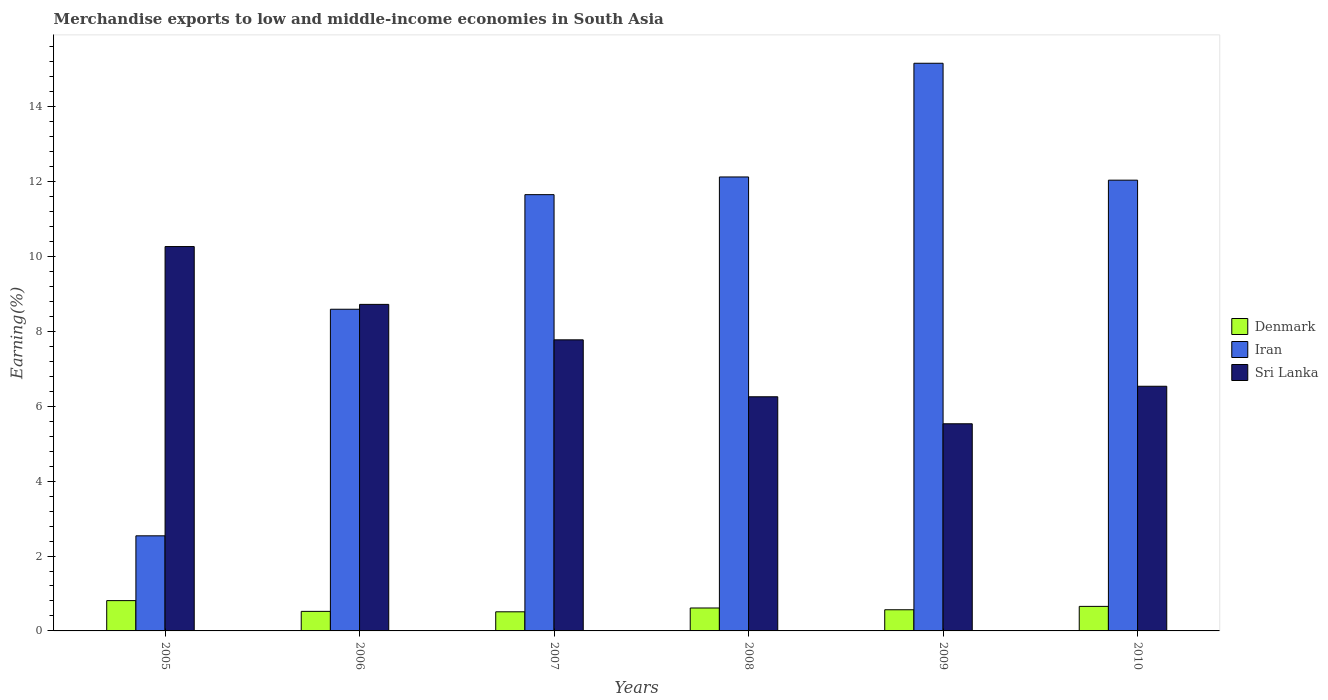How many different coloured bars are there?
Keep it short and to the point. 3. How many groups of bars are there?
Your response must be concise. 6. Are the number of bars on each tick of the X-axis equal?
Offer a terse response. Yes. How many bars are there on the 2nd tick from the right?
Make the answer very short. 3. What is the percentage of amount earned from merchandise exports in Sri Lanka in 2005?
Your answer should be compact. 10.27. Across all years, what is the maximum percentage of amount earned from merchandise exports in Sri Lanka?
Offer a terse response. 10.27. Across all years, what is the minimum percentage of amount earned from merchandise exports in Sri Lanka?
Your response must be concise. 5.53. In which year was the percentage of amount earned from merchandise exports in Iran minimum?
Keep it short and to the point. 2005. What is the total percentage of amount earned from merchandise exports in Denmark in the graph?
Offer a terse response. 3.68. What is the difference between the percentage of amount earned from merchandise exports in Iran in 2007 and that in 2009?
Give a very brief answer. -3.51. What is the difference between the percentage of amount earned from merchandise exports in Iran in 2005 and the percentage of amount earned from merchandise exports in Sri Lanka in 2006?
Make the answer very short. -6.18. What is the average percentage of amount earned from merchandise exports in Denmark per year?
Provide a succinct answer. 0.61. In the year 2007, what is the difference between the percentage of amount earned from merchandise exports in Denmark and percentage of amount earned from merchandise exports in Iran?
Your response must be concise. -11.14. In how many years, is the percentage of amount earned from merchandise exports in Iran greater than 11.6 %?
Your response must be concise. 4. What is the ratio of the percentage of amount earned from merchandise exports in Denmark in 2005 to that in 2008?
Offer a terse response. 1.32. Is the difference between the percentage of amount earned from merchandise exports in Denmark in 2006 and 2010 greater than the difference between the percentage of amount earned from merchandise exports in Iran in 2006 and 2010?
Your response must be concise. Yes. What is the difference between the highest and the second highest percentage of amount earned from merchandise exports in Denmark?
Your answer should be compact. 0.15. What is the difference between the highest and the lowest percentage of amount earned from merchandise exports in Denmark?
Your response must be concise. 0.3. In how many years, is the percentage of amount earned from merchandise exports in Sri Lanka greater than the average percentage of amount earned from merchandise exports in Sri Lanka taken over all years?
Provide a succinct answer. 3. What does the 2nd bar from the left in 2006 represents?
Provide a succinct answer. Iran. What does the 3rd bar from the right in 2010 represents?
Provide a short and direct response. Denmark. Is it the case that in every year, the sum of the percentage of amount earned from merchandise exports in Denmark and percentage of amount earned from merchandise exports in Sri Lanka is greater than the percentage of amount earned from merchandise exports in Iran?
Your answer should be compact. No. How many bars are there?
Offer a very short reply. 18. How many years are there in the graph?
Provide a succinct answer. 6. Does the graph contain any zero values?
Offer a very short reply. No. Does the graph contain grids?
Offer a very short reply. No. Where does the legend appear in the graph?
Offer a very short reply. Center right. How are the legend labels stacked?
Keep it short and to the point. Vertical. What is the title of the graph?
Offer a terse response. Merchandise exports to low and middle-income economies in South Asia. Does "Congo (Republic)" appear as one of the legend labels in the graph?
Give a very brief answer. No. What is the label or title of the Y-axis?
Keep it short and to the point. Earning(%). What is the Earning(%) of Denmark in 2005?
Provide a short and direct response. 0.81. What is the Earning(%) of Iran in 2005?
Make the answer very short. 2.54. What is the Earning(%) of Sri Lanka in 2005?
Offer a very short reply. 10.27. What is the Earning(%) in Denmark in 2006?
Make the answer very short. 0.52. What is the Earning(%) in Iran in 2006?
Provide a succinct answer. 8.59. What is the Earning(%) in Sri Lanka in 2006?
Give a very brief answer. 8.72. What is the Earning(%) in Denmark in 2007?
Your answer should be very brief. 0.51. What is the Earning(%) of Iran in 2007?
Your response must be concise. 11.65. What is the Earning(%) in Sri Lanka in 2007?
Make the answer very short. 7.78. What is the Earning(%) in Denmark in 2008?
Give a very brief answer. 0.61. What is the Earning(%) in Iran in 2008?
Offer a terse response. 12.13. What is the Earning(%) in Sri Lanka in 2008?
Make the answer very short. 6.25. What is the Earning(%) of Denmark in 2009?
Provide a succinct answer. 0.57. What is the Earning(%) in Iran in 2009?
Provide a short and direct response. 15.16. What is the Earning(%) in Sri Lanka in 2009?
Your answer should be very brief. 5.53. What is the Earning(%) in Denmark in 2010?
Provide a short and direct response. 0.66. What is the Earning(%) of Iran in 2010?
Ensure brevity in your answer.  12.04. What is the Earning(%) in Sri Lanka in 2010?
Make the answer very short. 6.54. Across all years, what is the maximum Earning(%) in Denmark?
Make the answer very short. 0.81. Across all years, what is the maximum Earning(%) in Iran?
Offer a very short reply. 15.16. Across all years, what is the maximum Earning(%) in Sri Lanka?
Your answer should be compact. 10.27. Across all years, what is the minimum Earning(%) in Denmark?
Your answer should be compact. 0.51. Across all years, what is the minimum Earning(%) in Iran?
Make the answer very short. 2.54. Across all years, what is the minimum Earning(%) in Sri Lanka?
Keep it short and to the point. 5.53. What is the total Earning(%) of Denmark in the graph?
Offer a very short reply. 3.68. What is the total Earning(%) in Iran in the graph?
Your answer should be compact. 62.12. What is the total Earning(%) in Sri Lanka in the graph?
Provide a succinct answer. 45.09. What is the difference between the Earning(%) of Denmark in 2005 and that in 2006?
Make the answer very short. 0.29. What is the difference between the Earning(%) in Iran in 2005 and that in 2006?
Ensure brevity in your answer.  -6.05. What is the difference between the Earning(%) in Sri Lanka in 2005 and that in 2006?
Provide a short and direct response. 1.54. What is the difference between the Earning(%) of Denmark in 2005 and that in 2007?
Provide a succinct answer. 0.3. What is the difference between the Earning(%) in Iran in 2005 and that in 2007?
Ensure brevity in your answer.  -9.11. What is the difference between the Earning(%) of Sri Lanka in 2005 and that in 2007?
Ensure brevity in your answer.  2.49. What is the difference between the Earning(%) of Denmark in 2005 and that in 2008?
Your answer should be compact. 0.2. What is the difference between the Earning(%) in Iran in 2005 and that in 2008?
Offer a very short reply. -9.59. What is the difference between the Earning(%) in Sri Lanka in 2005 and that in 2008?
Provide a succinct answer. 4.01. What is the difference between the Earning(%) in Denmark in 2005 and that in 2009?
Ensure brevity in your answer.  0.24. What is the difference between the Earning(%) in Iran in 2005 and that in 2009?
Give a very brief answer. -12.62. What is the difference between the Earning(%) of Sri Lanka in 2005 and that in 2009?
Your answer should be compact. 4.73. What is the difference between the Earning(%) in Denmark in 2005 and that in 2010?
Your answer should be very brief. 0.15. What is the difference between the Earning(%) of Iran in 2005 and that in 2010?
Your response must be concise. -9.5. What is the difference between the Earning(%) in Sri Lanka in 2005 and that in 2010?
Your answer should be very brief. 3.73. What is the difference between the Earning(%) in Denmark in 2006 and that in 2007?
Keep it short and to the point. 0.01. What is the difference between the Earning(%) in Iran in 2006 and that in 2007?
Offer a very short reply. -3.06. What is the difference between the Earning(%) of Sri Lanka in 2006 and that in 2007?
Offer a terse response. 0.95. What is the difference between the Earning(%) of Denmark in 2006 and that in 2008?
Offer a very short reply. -0.09. What is the difference between the Earning(%) in Iran in 2006 and that in 2008?
Make the answer very short. -3.53. What is the difference between the Earning(%) of Sri Lanka in 2006 and that in 2008?
Your answer should be compact. 2.47. What is the difference between the Earning(%) in Denmark in 2006 and that in 2009?
Your answer should be very brief. -0.04. What is the difference between the Earning(%) of Iran in 2006 and that in 2009?
Offer a very short reply. -6.57. What is the difference between the Earning(%) in Sri Lanka in 2006 and that in 2009?
Offer a terse response. 3.19. What is the difference between the Earning(%) of Denmark in 2006 and that in 2010?
Your answer should be compact. -0.13. What is the difference between the Earning(%) of Iran in 2006 and that in 2010?
Provide a short and direct response. -3.45. What is the difference between the Earning(%) in Sri Lanka in 2006 and that in 2010?
Give a very brief answer. 2.19. What is the difference between the Earning(%) of Denmark in 2007 and that in 2008?
Give a very brief answer. -0.1. What is the difference between the Earning(%) of Iran in 2007 and that in 2008?
Give a very brief answer. -0.47. What is the difference between the Earning(%) of Sri Lanka in 2007 and that in 2008?
Provide a succinct answer. 1.52. What is the difference between the Earning(%) in Denmark in 2007 and that in 2009?
Offer a very short reply. -0.05. What is the difference between the Earning(%) in Iran in 2007 and that in 2009?
Offer a terse response. -3.51. What is the difference between the Earning(%) of Sri Lanka in 2007 and that in 2009?
Make the answer very short. 2.24. What is the difference between the Earning(%) of Denmark in 2007 and that in 2010?
Give a very brief answer. -0.14. What is the difference between the Earning(%) of Iran in 2007 and that in 2010?
Provide a short and direct response. -0.39. What is the difference between the Earning(%) of Sri Lanka in 2007 and that in 2010?
Provide a succinct answer. 1.24. What is the difference between the Earning(%) in Denmark in 2008 and that in 2009?
Make the answer very short. 0.05. What is the difference between the Earning(%) of Iran in 2008 and that in 2009?
Offer a very short reply. -3.04. What is the difference between the Earning(%) in Sri Lanka in 2008 and that in 2009?
Offer a terse response. 0.72. What is the difference between the Earning(%) in Denmark in 2008 and that in 2010?
Provide a succinct answer. -0.04. What is the difference between the Earning(%) in Iran in 2008 and that in 2010?
Provide a short and direct response. 0.09. What is the difference between the Earning(%) of Sri Lanka in 2008 and that in 2010?
Offer a very short reply. -0.28. What is the difference between the Earning(%) of Denmark in 2009 and that in 2010?
Your answer should be compact. -0.09. What is the difference between the Earning(%) of Iran in 2009 and that in 2010?
Make the answer very short. 3.12. What is the difference between the Earning(%) of Sri Lanka in 2009 and that in 2010?
Your response must be concise. -1. What is the difference between the Earning(%) in Denmark in 2005 and the Earning(%) in Iran in 2006?
Your answer should be very brief. -7.78. What is the difference between the Earning(%) of Denmark in 2005 and the Earning(%) of Sri Lanka in 2006?
Your response must be concise. -7.91. What is the difference between the Earning(%) of Iran in 2005 and the Earning(%) of Sri Lanka in 2006?
Ensure brevity in your answer.  -6.18. What is the difference between the Earning(%) of Denmark in 2005 and the Earning(%) of Iran in 2007?
Provide a succinct answer. -10.84. What is the difference between the Earning(%) in Denmark in 2005 and the Earning(%) in Sri Lanka in 2007?
Your answer should be compact. -6.97. What is the difference between the Earning(%) in Iran in 2005 and the Earning(%) in Sri Lanka in 2007?
Provide a short and direct response. -5.24. What is the difference between the Earning(%) of Denmark in 2005 and the Earning(%) of Iran in 2008?
Give a very brief answer. -11.32. What is the difference between the Earning(%) of Denmark in 2005 and the Earning(%) of Sri Lanka in 2008?
Offer a very short reply. -5.45. What is the difference between the Earning(%) in Iran in 2005 and the Earning(%) in Sri Lanka in 2008?
Your answer should be very brief. -3.71. What is the difference between the Earning(%) in Denmark in 2005 and the Earning(%) in Iran in 2009?
Keep it short and to the point. -14.35. What is the difference between the Earning(%) of Denmark in 2005 and the Earning(%) of Sri Lanka in 2009?
Provide a short and direct response. -4.72. What is the difference between the Earning(%) of Iran in 2005 and the Earning(%) of Sri Lanka in 2009?
Offer a very short reply. -2.99. What is the difference between the Earning(%) of Denmark in 2005 and the Earning(%) of Iran in 2010?
Your response must be concise. -11.23. What is the difference between the Earning(%) in Denmark in 2005 and the Earning(%) in Sri Lanka in 2010?
Keep it short and to the point. -5.73. What is the difference between the Earning(%) of Iran in 2005 and the Earning(%) of Sri Lanka in 2010?
Make the answer very short. -4. What is the difference between the Earning(%) in Denmark in 2006 and the Earning(%) in Iran in 2007?
Offer a very short reply. -11.13. What is the difference between the Earning(%) in Denmark in 2006 and the Earning(%) in Sri Lanka in 2007?
Ensure brevity in your answer.  -7.25. What is the difference between the Earning(%) in Iran in 2006 and the Earning(%) in Sri Lanka in 2007?
Offer a terse response. 0.82. What is the difference between the Earning(%) of Denmark in 2006 and the Earning(%) of Iran in 2008?
Offer a very short reply. -11.6. What is the difference between the Earning(%) in Denmark in 2006 and the Earning(%) in Sri Lanka in 2008?
Keep it short and to the point. -5.73. What is the difference between the Earning(%) in Iran in 2006 and the Earning(%) in Sri Lanka in 2008?
Keep it short and to the point. 2.34. What is the difference between the Earning(%) in Denmark in 2006 and the Earning(%) in Iran in 2009?
Offer a terse response. -14.64. What is the difference between the Earning(%) of Denmark in 2006 and the Earning(%) of Sri Lanka in 2009?
Offer a very short reply. -5.01. What is the difference between the Earning(%) of Iran in 2006 and the Earning(%) of Sri Lanka in 2009?
Keep it short and to the point. 3.06. What is the difference between the Earning(%) in Denmark in 2006 and the Earning(%) in Iran in 2010?
Ensure brevity in your answer.  -11.52. What is the difference between the Earning(%) in Denmark in 2006 and the Earning(%) in Sri Lanka in 2010?
Provide a succinct answer. -6.01. What is the difference between the Earning(%) in Iran in 2006 and the Earning(%) in Sri Lanka in 2010?
Offer a terse response. 2.06. What is the difference between the Earning(%) in Denmark in 2007 and the Earning(%) in Iran in 2008?
Make the answer very short. -11.62. What is the difference between the Earning(%) of Denmark in 2007 and the Earning(%) of Sri Lanka in 2008?
Offer a terse response. -5.74. What is the difference between the Earning(%) of Iran in 2007 and the Earning(%) of Sri Lanka in 2008?
Provide a succinct answer. 5.4. What is the difference between the Earning(%) of Denmark in 2007 and the Earning(%) of Iran in 2009?
Make the answer very short. -14.65. What is the difference between the Earning(%) of Denmark in 2007 and the Earning(%) of Sri Lanka in 2009?
Give a very brief answer. -5.02. What is the difference between the Earning(%) of Iran in 2007 and the Earning(%) of Sri Lanka in 2009?
Keep it short and to the point. 6.12. What is the difference between the Earning(%) of Denmark in 2007 and the Earning(%) of Iran in 2010?
Make the answer very short. -11.53. What is the difference between the Earning(%) in Denmark in 2007 and the Earning(%) in Sri Lanka in 2010?
Provide a succinct answer. -6.02. What is the difference between the Earning(%) of Iran in 2007 and the Earning(%) of Sri Lanka in 2010?
Your response must be concise. 5.12. What is the difference between the Earning(%) in Denmark in 2008 and the Earning(%) in Iran in 2009?
Provide a succinct answer. -14.55. What is the difference between the Earning(%) in Denmark in 2008 and the Earning(%) in Sri Lanka in 2009?
Your answer should be very brief. -4.92. What is the difference between the Earning(%) in Iran in 2008 and the Earning(%) in Sri Lanka in 2009?
Offer a terse response. 6.59. What is the difference between the Earning(%) in Denmark in 2008 and the Earning(%) in Iran in 2010?
Your answer should be very brief. -11.43. What is the difference between the Earning(%) in Denmark in 2008 and the Earning(%) in Sri Lanka in 2010?
Make the answer very short. -5.92. What is the difference between the Earning(%) in Iran in 2008 and the Earning(%) in Sri Lanka in 2010?
Provide a short and direct response. 5.59. What is the difference between the Earning(%) of Denmark in 2009 and the Earning(%) of Iran in 2010?
Your answer should be very brief. -11.48. What is the difference between the Earning(%) of Denmark in 2009 and the Earning(%) of Sri Lanka in 2010?
Offer a very short reply. -5.97. What is the difference between the Earning(%) of Iran in 2009 and the Earning(%) of Sri Lanka in 2010?
Offer a very short reply. 8.63. What is the average Earning(%) of Denmark per year?
Make the answer very short. 0.61. What is the average Earning(%) of Iran per year?
Ensure brevity in your answer.  10.35. What is the average Earning(%) of Sri Lanka per year?
Your answer should be very brief. 7.51. In the year 2005, what is the difference between the Earning(%) of Denmark and Earning(%) of Iran?
Your response must be concise. -1.73. In the year 2005, what is the difference between the Earning(%) of Denmark and Earning(%) of Sri Lanka?
Provide a succinct answer. -9.46. In the year 2005, what is the difference between the Earning(%) in Iran and Earning(%) in Sri Lanka?
Your answer should be compact. -7.73. In the year 2006, what is the difference between the Earning(%) in Denmark and Earning(%) in Iran?
Provide a short and direct response. -8.07. In the year 2006, what is the difference between the Earning(%) of Denmark and Earning(%) of Sri Lanka?
Offer a very short reply. -8.2. In the year 2006, what is the difference between the Earning(%) in Iran and Earning(%) in Sri Lanka?
Provide a short and direct response. -0.13. In the year 2007, what is the difference between the Earning(%) in Denmark and Earning(%) in Iran?
Make the answer very short. -11.14. In the year 2007, what is the difference between the Earning(%) of Denmark and Earning(%) of Sri Lanka?
Your answer should be very brief. -7.26. In the year 2007, what is the difference between the Earning(%) of Iran and Earning(%) of Sri Lanka?
Your answer should be very brief. 3.88. In the year 2008, what is the difference between the Earning(%) in Denmark and Earning(%) in Iran?
Keep it short and to the point. -11.51. In the year 2008, what is the difference between the Earning(%) in Denmark and Earning(%) in Sri Lanka?
Offer a terse response. -5.64. In the year 2008, what is the difference between the Earning(%) of Iran and Earning(%) of Sri Lanka?
Your response must be concise. 5.87. In the year 2009, what is the difference between the Earning(%) in Denmark and Earning(%) in Iran?
Your answer should be very brief. -14.6. In the year 2009, what is the difference between the Earning(%) of Denmark and Earning(%) of Sri Lanka?
Provide a succinct answer. -4.97. In the year 2009, what is the difference between the Earning(%) of Iran and Earning(%) of Sri Lanka?
Your answer should be compact. 9.63. In the year 2010, what is the difference between the Earning(%) of Denmark and Earning(%) of Iran?
Provide a short and direct response. -11.39. In the year 2010, what is the difference between the Earning(%) of Denmark and Earning(%) of Sri Lanka?
Your answer should be compact. -5.88. In the year 2010, what is the difference between the Earning(%) of Iran and Earning(%) of Sri Lanka?
Provide a short and direct response. 5.51. What is the ratio of the Earning(%) in Denmark in 2005 to that in 2006?
Your answer should be compact. 1.55. What is the ratio of the Earning(%) in Iran in 2005 to that in 2006?
Make the answer very short. 0.3. What is the ratio of the Earning(%) in Sri Lanka in 2005 to that in 2006?
Your answer should be very brief. 1.18. What is the ratio of the Earning(%) of Denmark in 2005 to that in 2007?
Offer a very short reply. 1.58. What is the ratio of the Earning(%) of Iran in 2005 to that in 2007?
Offer a very short reply. 0.22. What is the ratio of the Earning(%) in Sri Lanka in 2005 to that in 2007?
Ensure brevity in your answer.  1.32. What is the ratio of the Earning(%) in Denmark in 2005 to that in 2008?
Offer a very short reply. 1.32. What is the ratio of the Earning(%) in Iran in 2005 to that in 2008?
Make the answer very short. 0.21. What is the ratio of the Earning(%) of Sri Lanka in 2005 to that in 2008?
Offer a terse response. 1.64. What is the ratio of the Earning(%) in Denmark in 2005 to that in 2009?
Ensure brevity in your answer.  1.43. What is the ratio of the Earning(%) of Iran in 2005 to that in 2009?
Give a very brief answer. 0.17. What is the ratio of the Earning(%) in Sri Lanka in 2005 to that in 2009?
Make the answer very short. 1.86. What is the ratio of the Earning(%) of Denmark in 2005 to that in 2010?
Offer a terse response. 1.23. What is the ratio of the Earning(%) in Iran in 2005 to that in 2010?
Offer a very short reply. 0.21. What is the ratio of the Earning(%) in Sri Lanka in 2005 to that in 2010?
Offer a very short reply. 1.57. What is the ratio of the Earning(%) of Denmark in 2006 to that in 2007?
Make the answer very short. 1.02. What is the ratio of the Earning(%) in Iran in 2006 to that in 2007?
Your answer should be compact. 0.74. What is the ratio of the Earning(%) of Sri Lanka in 2006 to that in 2007?
Offer a very short reply. 1.12. What is the ratio of the Earning(%) in Denmark in 2006 to that in 2008?
Give a very brief answer. 0.85. What is the ratio of the Earning(%) of Iran in 2006 to that in 2008?
Your response must be concise. 0.71. What is the ratio of the Earning(%) in Sri Lanka in 2006 to that in 2008?
Provide a succinct answer. 1.39. What is the ratio of the Earning(%) of Denmark in 2006 to that in 2009?
Offer a very short reply. 0.92. What is the ratio of the Earning(%) of Iran in 2006 to that in 2009?
Give a very brief answer. 0.57. What is the ratio of the Earning(%) of Sri Lanka in 2006 to that in 2009?
Offer a very short reply. 1.58. What is the ratio of the Earning(%) of Denmark in 2006 to that in 2010?
Your answer should be compact. 0.8. What is the ratio of the Earning(%) in Iran in 2006 to that in 2010?
Your answer should be very brief. 0.71. What is the ratio of the Earning(%) of Sri Lanka in 2006 to that in 2010?
Offer a very short reply. 1.33. What is the ratio of the Earning(%) in Denmark in 2007 to that in 2008?
Offer a very short reply. 0.83. What is the ratio of the Earning(%) in Iran in 2007 to that in 2008?
Provide a succinct answer. 0.96. What is the ratio of the Earning(%) in Sri Lanka in 2007 to that in 2008?
Provide a short and direct response. 1.24. What is the ratio of the Earning(%) in Denmark in 2007 to that in 2009?
Offer a very short reply. 0.9. What is the ratio of the Earning(%) of Iran in 2007 to that in 2009?
Ensure brevity in your answer.  0.77. What is the ratio of the Earning(%) of Sri Lanka in 2007 to that in 2009?
Your answer should be very brief. 1.41. What is the ratio of the Earning(%) in Denmark in 2007 to that in 2010?
Give a very brief answer. 0.78. What is the ratio of the Earning(%) of Iran in 2007 to that in 2010?
Provide a short and direct response. 0.97. What is the ratio of the Earning(%) of Sri Lanka in 2007 to that in 2010?
Give a very brief answer. 1.19. What is the ratio of the Earning(%) of Denmark in 2008 to that in 2009?
Keep it short and to the point. 1.08. What is the ratio of the Earning(%) in Iran in 2008 to that in 2009?
Ensure brevity in your answer.  0.8. What is the ratio of the Earning(%) of Sri Lanka in 2008 to that in 2009?
Your answer should be compact. 1.13. What is the ratio of the Earning(%) in Denmark in 2008 to that in 2010?
Your answer should be very brief. 0.93. What is the ratio of the Earning(%) of Iran in 2008 to that in 2010?
Your answer should be very brief. 1.01. What is the ratio of the Earning(%) of Sri Lanka in 2008 to that in 2010?
Provide a short and direct response. 0.96. What is the ratio of the Earning(%) in Denmark in 2009 to that in 2010?
Offer a terse response. 0.86. What is the ratio of the Earning(%) of Iran in 2009 to that in 2010?
Provide a succinct answer. 1.26. What is the ratio of the Earning(%) in Sri Lanka in 2009 to that in 2010?
Keep it short and to the point. 0.85. What is the difference between the highest and the second highest Earning(%) in Denmark?
Provide a short and direct response. 0.15. What is the difference between the highest and the second highest Earning(%) of Iran?
Provide a succinct answer. 3.04. What is the difference between the highest and the second highest Earning(%) in Sri Lanka?
Keep it short and to the point. 1.54. What is the difference between the highest and the lowest Earning(%) in Denmark?
Ensure brevity in your answer.  0.3. What is the difference between the highest and the lowest Earning(%) of Iran?
Keep it short and to the point. 12.62. What is the difference between the highest and the lowest Earning(%) in Sri Lanka?
Offer a terse response. 4.73. 